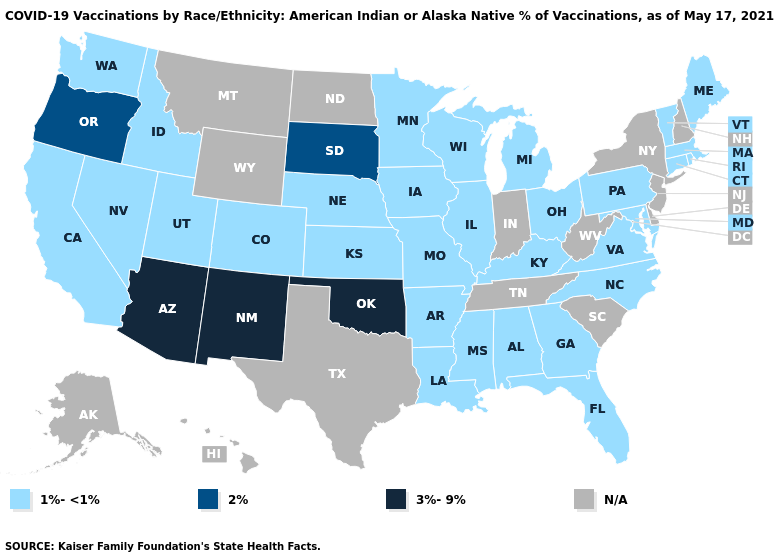What is the value of Pennsylvania?
Be succinct. 1%-<1%. What is the value of Arkansas?
Give a very brief answer. 1%-<1%. What is the highest value in states that border Utah?
Quick response, please. 3%-9%. Does Colorado have the highest value in the West?
Be succinct. No. What is the lowest value in states that border Ohio?
Give a very brief answer. 1%-<1%. Name the states that have a value in the range 1%-<1%?
Quick response, please. Alabama, Arkansas, California, Colorado, Connecticut, Florida, Georgia, Idaho, Illinois, Iowa, Kansas, Kentucky, Louisiana, Maine, Maryland, Massachusetts, Michigan, Minnesota, Mississippi, Missouri, Nebraska, Nevada, North Carolina, Ohio, Pennsylvania, Rhode Island, Utah, Vermont, Virginia, Washington, Wisconsin. Name the states that have a value in the range 1%-<1%?
Short answer required. Alabama, Arkansas, California, Colorado, Connecticut, Florida, Georgia, Idaho, Illinois, Iowa, Kansas, Kentucky, Louisiana, Maine, Maryland, Massachusetts, Michigan, Minnesota, Mississippi, Missouri, Nebraska, Nevada, North Carolina, Ohio, Pennsylvania, Rhode Island, Utah, Vermont, Virginia, Washington, Wisconsin. What is the value of Kentucky?
Quick response, please. 1%-<1%. What is the lowest value in the USA?
Be succinct. 1%-<1%. What is the value of Georgia?
Quick response, please. 1%-<1%. Which states have the lowest value in the USA?
Give a very brief answer. Alabama, Arkansas, California, Colorado, Connecticut, Florida, Georgia, Idaho, Illinois, Iowa, Kansas, Kentucky, Louisiana, Maine, Maryland, Massachusetts, Michigan, Minnesota, Mississippi, Missouri, Nebraska, Nevada, North Carolina, Ohio, Pennsylvania, Rhode Island, Utah, Vermont, Virginia, Washington, Wisconsin. What is the value of Vermont?
Short answer required. 1%-<1%. What is the value of Ohio?
Quick response, please. 1%-<1%. 